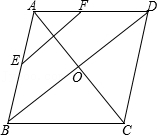Can you explain the significance of the point O and how it relates to the rest of the figure? Point O in the diagram is the intersection of the diagonals AC and BD of the diamond-shaped quadrilateral ABCD. In diamond-shaped figures, or rhombi, the diagonals are perpendicular bisectors of each other and meet at right angles. This point, therefore, also represents the center of symmetry for the quadrilateral, suggesting that any line passing through O and extending in opposite directions is symmetrical.  What does the positioning of points E and F tell us about the quadrilateral? The positioning of points E and F at the midpoints of sides AB and AD respectively suggests that EF could be one of the lines of symmetry if ABCD is a kite or another symmetrical quadrilateral. Additionally, these points can be used to discuss properties like sections of lines or ratios in the context of similar triangles formed within the diagram. 